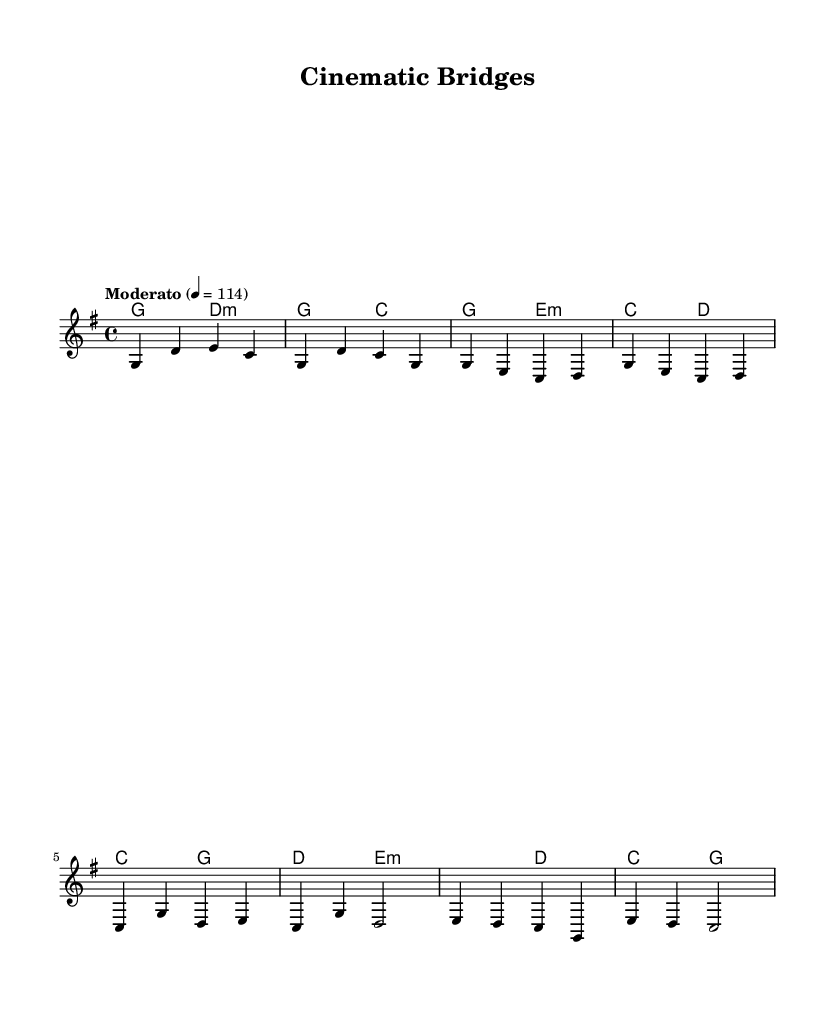What is the key signature of this music? The key signature is G major, which has one sharp (F#). This can be identified by looking at the beginning of the staff where the key signature is indicated.
Answer: G major What is the time signature of this music? The time signature is 4/4, indicated at the beginning of the score. This means there are four beats in each measure and the quarter note gets one beat.
Answer: 4/4 What is the tempo marking of this piece? The tempo marking is "Moderato," which typically refers to a moderate speed of music, and is indicated at the beginning of the score.
Answer: Moderato What is the first chord in the introduction? The first chord in the introduction is G major, which is specified in the harmonies section as the chord played at the start of the piece.
Answer: G major How many measures are in the choruses section as shown? There are two measures in the chorus, as indicated by the number of groupings of notes in that section of the sheet music.
Answer: 2 What is the structure type of this music piece? The structure includes an intro, verses, a chorus, and a bridge, demonstrating a common song structure, particularly in country rock.
Answer: Verse-Chorus Which chords are used in the bridge section? The chords used in the bridge section are E minor and D major, as seen in the harmonies section for the bridge part.
Answer: E minor, D major 